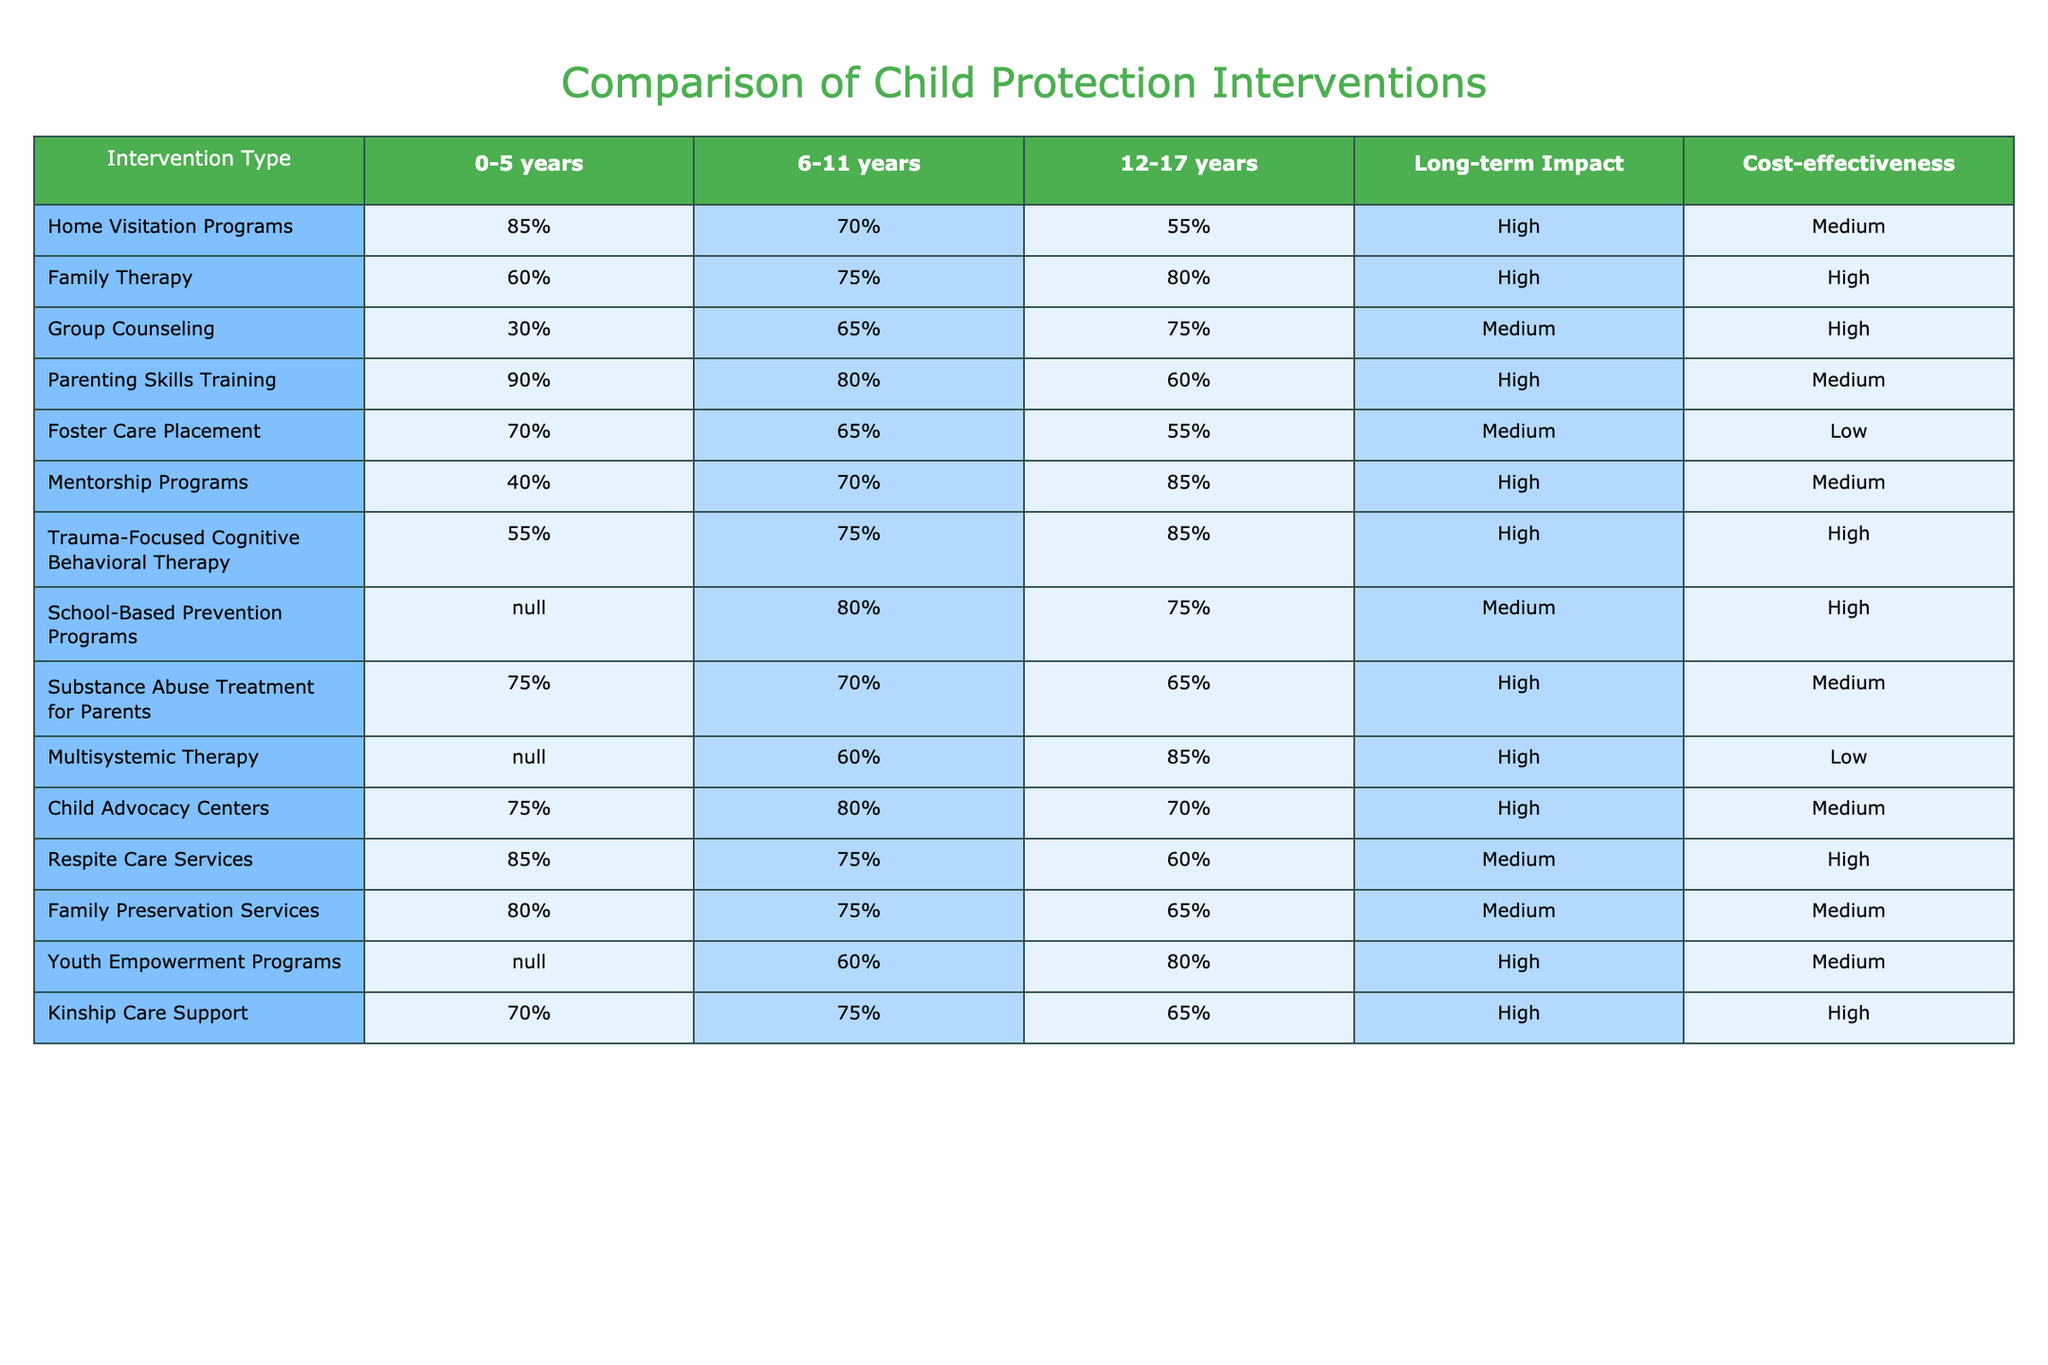What intervention has the highest effectiveness for children aged 0-5 years? Looking at the "0-5 years" column, Parenting Skills Training has the highest effectiveness at 90%.
Answer: Parenting Skills Training Which intervention type has a long-term impact that is rated high in effectiveness? By scanning the "Long-term Impact" column, we can see that Home Visitation Programs, Family Therapy, Mentorship Programs, Trauma-Focused Cognitive Behavioral Therapy, Child Advocacy Centers, Substance Abuse Treatment for Parents, Kinship Care Support, and Parenting Skills Training all have a high rating for long-term impact.
Answer: Home Visitation Programs, Family Therapy, Mentorship Programs, Trauma-Focused Cognitive Behavioral Therapy, Child Advocacy Centers, Substance Abuse Treatment for Parents, Kinship Care Support, Parenting Skills Training Is Foster Care Placement cost-effective? In the "Cost-effectiveness" column, Foster Care Placement is rated low, which indicates that it's not cost-effective.
Answer: No What is the average effectiveness of interventions for children aged 6-11 years? First, we will sum the effectiveness rates for children aged 6-11 years: (70% + 75% + 65% + 80% + 70% + 60% + 80% + 75% + 75% + 75%) =  71.5%. There are 10 interventions, so the average effectiveness is 715% ÷ 10 = 71.5%.
Answer: 71.5% What intervention type has the lowest effectiveness for adolescents (12-17 years)? To find the lowest effectiveness for 12-17 years, we look at the effectiveness percentages and find that Foster Care Placement has the lowest effectiveness at 55%.
Answer: Foster Care Placement Which two interventions are equally effective for 12-17 years and have a high long-term impact? By checking the "12-17 years" column, both Family Therapy and Trauma-Focused Cognitive Behavioral Therapy score 85%, and they are also marked as high for long-term impact.
Answer: Family Therapy and Trauma-Focused Cognitive Behavioral Therapy Is there an intervention type that shows effectiveness improving as child age increases? Assessing the effectiveness rates across age groups, Mentorship Programs and Trauma-Focused Cognitive Behavioral Therapy have increasing effectiveness from the younger age group to the older. Therefore, the answer is yes, there are intervention types that show improvement.
Answer: Yes What is the difference in effectiveness between the best and worst interventions for 6-11 year-olds? The best intervention for 6-11 year-olds is School-Based Prevention Programs (80%) and the worst is Group Counseling (65%). Thus, the difference is 80% - 65% = 15%.
Answer: 15% 